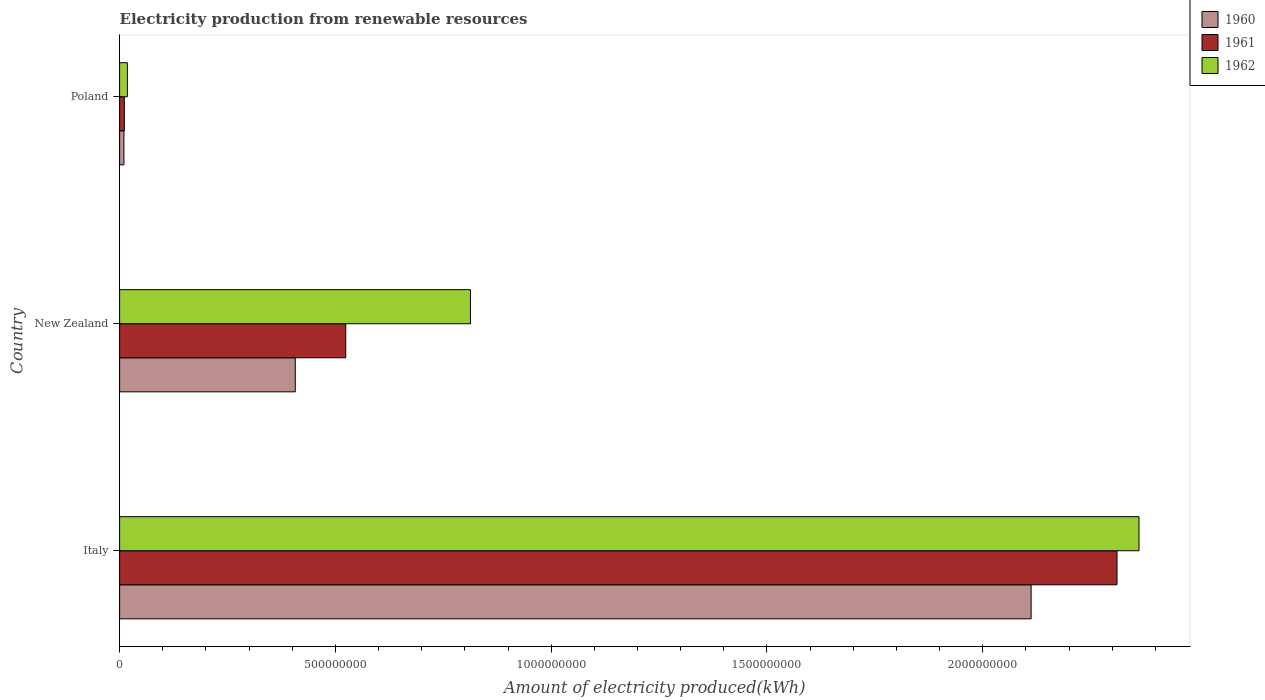How many different coloured bars are there?
Provide a succinct answer. 3. How many bars are there on the 2nd tick from the top?
Provide a short and direct response. 3. What is the amount of electricity produced in 1961 in New Zealand?
Ensure brevity in your answer.  5.24e+08. Across all countries, what is the maximum amount of electricity produced in 1962?
Provide a succinct answer. 2.36e+09. Across all countries, what is the minimum amount of electricity produced in 1962?
Your answer should be compact. 1.80e+07. In which country was the amount of electricity produced in 1962 minimum?
Your answer should be compact. Poland. What is the total amount of electricity produced in 1960 in the graph?
Ensure brevity in your answer.  2.53e+09. What is the difference between the amount of electricity produced in 1961 in New Zealand and that in Poland?
Offer a terse response. 5.13e+08. What is the difference between the amount of electricity produced in 1961 in Poland and the amount of electricity produced in 1960 in Italy?
Your answer should be very brief. -2.10e+09. What is the average amount of electricity produced in 1962 per country?
Ensure brevity in your answer.  1.06e+09. In how many countries, is the amount of electricity produced in 1962 greater than 700000000 kWh?
Your answer should be compact. 2. What is the ratio of the amount of electricity produced in 1961 in Italy to that in New Zealand?
Your answer should be compact. 4.41. What is the difference between the highest and the second highest amount of electricity produced in 1962?
Your answer should be very brief. 1.55e+09. What is the difference between the highest and the lowest amount of electricity produced in 1960?
Your answer should be very brief. 2.10e+09. Is it the case that in every country, the sum of the amount of electricity produced in 1961 and amount of electricity produced in 1960 is greater than the amount of electricity produced in 1962?
Provide a succinct answer. Yes. How many bars are there?
Keep it short and to the point. 9. Are all the bars in the graph horizontal?
Give a very brief answer. Yes. Does the graph contain any zero values?
Provide a short and direct response. No. Where does the legend appear in the graph?
Your response must be concise. Top right. How are the legend labels stacked?
Give a very brief answer. Vertical. What is the title of the graph?
Ensure brevity in your answer.  Electricity production from renewable resources. Does "1990" appear as one of the legend labels in the graph?
Offer a terse response. No. What is the label or title of the X-axis?
Provide a short and direct response. Amount of electricity produced(kWh). What is the label or title of the Y-axis?
Your response must be concise. Country. What is the Amount of electricity produced(kWh) in 1960 in Italy?
Keep it short and to the point. 2.11e+09. What is the Amount of electricity produced(kWh) in 1961 in Italy?
Ensure brevity in your answer.  2.31e+09. What is the Amount of electricity produced(kWh) in 1962 in Italy?
Your response must be concise. 2.36e+09. What is the Amount of electricity produced(kWh) of 1960 in New Zealand?
Make the answer very short. 4.07e+08. What is the Amount of electricity produced(kWh) in 1961 in New Zealand?
Your answer should be compact. 5.24e+08. What is the Amount of electricity produced(kWh) in 1962 in New Zealand?
Give a very brief answer. 8.13e+08. What is the Amount of electricity produced(kWh) of 1961 in Poland?
Your response must be concise. 1.10e+07. What is the Amount of electricity produced(kWh) of 1962 in Poland?
Ensure brevity in your answer.  1.80e+07. Across all countries, what is the maximum Amount of electricity produced(kWh) in 1960?
Your response must be concise. 2.11e+09. Across all countries, what is the maximum Amount of electricity produced(kWh) of 1961?
Your answer should be compact. 2.31e+09. Across all countries, what is the maximum Amount of electricity produced(kWh) in 1962?
Offer a terse response. 2.36e+09. Across all countries, what is the minimum Amount of electricity produced(kWh) in 1961?
Keep it short and to the point. 1.10e+07. Across all countries, what is the minimum Amount of electricity produced(kWh) of 1962?
Your answer should be very brief. 1.80e+07. What is the total Amount of electricity produced(kWh) of 1960 in the graph?
Provide a short and direct response. 2.53e+09. What is the total Amount of electricity produced(kWh) in 1961 in the graph?
Keep it short and to the point. 2.85e+09. What is the total Amount of electricity produced(kWh) in 1962 in the graph?
Offer a terse response. 3.19e+09. What is the difference between the Amount of electricity produced(kWh) of 1960 in Italy and that in New Zealand?
Ensure brevity in your answer.  1.70e+09. What is the difference between the Amount of electricity produced(kWh) in 1961 in Italy and that in New Zealand?
Give a very brief answer. 1.79e+09. What is the difference between the Amount of electricity produced(kWh) in 1962 in Italy and that in New Zealand?
Provide a succinct answer. 1.55e+09. What is the difference between the Amount of electricity produced(kWh) of 1960 in Italy and that in Poland?
Ensure brevity in your answer.  2.10e+09. What is the difference between the Amount of electricity produced(kWh) of 1961 in Italy and that in Poland?
Make the answer very short. 2.30e+09. What is the difference between the Amount of electricity produced(kWh) of 1962 in Italy and that in Poland?
Make the answer very short. 2.34e+09. What is the difference between the Amount of electricity produced(kWh) of 1960 in New Zealand and that in Poland?
Make the answer very short. 3.97e+08. What is the difference between the Amount of electricity produced(kWh) of 1961 in New Zealand and that in Poland?
Your answer should be compact. 5.13e+08. What is the difference between the Amount of electricity produced(kWh) of 1962 in New Zealand and that in Poland?
Give a very brief answer. 7.95e+08. What is the difference between the Amount of electricity produced(kWh) of 1960 in Italy and the Amount of electricity produced(kWh) of 1961 in New Zealand?
Offer a terse response. 1.59e+09. What is the difference between the Amount of electricity produced(kWh) in 1960 in Italy and the Amount of electricity produced(kWh) in 1962 in New Zealand?
Offer a very short reply. 1.30e+09. What is the difference between the Amount of electricity produced(kWh) in 1961 in Italy and the Amount of electricity produced(kWh) in 1962 in New Zealand?
Ensure brevity in your answer.  1.50e+09. What is the difference between the Amount of electricity produced(kWh) of 1960 in Italy and the Amount of electricity produced(kWh) of 1961 in Poland?
Give a very brief answer. 2.10e+09. What is the difference between the Amount of electricity produced(kWh) of 1960 in Italy and the Amount of electricity produced(kWh) of 1962 in Poland?
Your answer should be compact. 2.09e+09. What is the difference between the Amount of electricity produced(kWh) of 1961 in Italy and the Amount of electricity produced(kWh) of 1962 in Poland?
Keep it short and to the point. 2.29e+09. What is the difference between the Amount of electricity produced(kWh) in 1960 in New Zealand and the Amount of electricity produced(kWh) in 1961 in Poland?
Offer a terse response. 3.96e+08. What is the difference between the Amount of electricity produced(kWh) in 1960 in New Zealand and the Amount of electricity produced(kWh) in 1962 in Poland?
Ensure brevity in your answer.  3.89e+08. What is the difference between the Amount of electricity produced(kWh) in 1961 in New Zealand and the Amount of electricity produced(kWh) in 1962 in Poland?
Provide a succinct answer. 5.06e+08. What is the average Amount of electricity produced(kWh) in 1960 per country?
Provide a short and direct response. 8.43e+08. What is the average Amount of electricity produced(kWh) of 1961 per country?
Ensure brevity in your answer.  9.49e+08. What is the average Amount of electricity produced(kWh) in 1962 per country?
Provide a short and direct response. 1.06e+09. What is the difference between the Amount of electricity produced(kWh) of 1960 and Amount of electricity produced(kWh) of 1961 in Italy?
Offer a terse response. -1.99e+08. What is the difference between the Amount of electricity produced(kWh) in 1960 and Amount of electricity produced(kWh) in 1962 in Italy?
Your response must be concise. -2.50e+08. What is the difference between the Amount of electricity produced(kWh) of 1961 and Amount of electricity produced(kWh) of 1962 in Italy?
Your response must be concise. -5.10e+07. What is the difference between the Amount of electricity produced(kWh) in 1960 and Amount of electricity produced(kWh) in 1961 in New Zealand?
Make the answer very short. -1.17e+08. What is the difference between the Amount of electricity produced(kWh) in 1960 and Amount of electricity produced(kWh) in 1962 in New Zealand?
Provide a short and direct response. -4.06e+08. What is the difference between the Amount of electricity produced(kWh) in 1961 and Amount of electricity produced(kWh) in 1962 in New Zealand?
Give a very brief answer. -2.89e+08. What is the difference between the Amount of electricity produced(kWh) of 1960 and Amount of electricity produced(kWh) of 1962 in Poland?
Offer a very short reply. -8.00e+06. What is the difference between the Amount of electricity produced(kWh) in 1961 and Amount of electricity produced(kWh) in 1962 in Poland?
Give a very brief answer. -7.00e+06. What is the ratio of the Amount of electricity produced(kWh) of 1960 in Italy to that in New Zealand?
Your answer should be compact. 5.19. What is the ratio of the Amount of electricity produced(kWh) of 1961 in Italy to that in New Zealand?
Your answer should be very brief. 4.41. What is the ratio of the Amount of electricity produced(kWh) of 1962 in Italy to that in New Zealand?
Provide a short and direct response. 2.91. What is the ratio of the Amount of electricity produced(kWh) in 1960 in Italy to that in Poland?
Your response must be concise. 211.2. What is the ratio of the Amount of electricity produced(kWh) of 1961 in Italy to that in Poland?
Provide a succinct answer. 210.09. What is the ratio of the Amount of electricity produced(kWh) in 1962 in Italy to that in Poland?
Offer a very short reply. 131.22. What is the ratio of the Amount of electricity produced(kWh) of 1960 in New Zealand to that in Poland?
Your answer should be compact. 40.7. What is the ratio of the Amount of electricity produced(kWh) of 1961 in New Zealand to that in Poland?
Your answer should be compact. 47.64. What is the ratio of the Amount of electricity produced(kWh) of 1962 in New Zealand to that in Poland?
Offer a terse response. 45.17. What is the difference between the highest and the second highest Amount of electricity produced(kWh) in 1960?
Keep it short and to the point. 1.70e+09. What is the difference between the highest and the second highest Amount of electricity produced(kWh) of 1961?
Ensure brevity in your answer.  1.79e+09. What is the difference between the highest and the second highest Amount of electricity produced(kWh) of 1962?
Your response must be concise. 1.55e+09. What is the difference between the highest and the lowest Amount of electricity produced(kWh) in 1960?
Offer a terse response. 2.10e+09. What is the difference between the highest and the lowest Amount of electricity produced(kWh) of 1961?
Keep it short and to the point. 2.30e+09. What is the difference between the highest and the lowest Amount of electricity produced(kWh) in 1962?
Make the answer very short. 2.34e+09. 